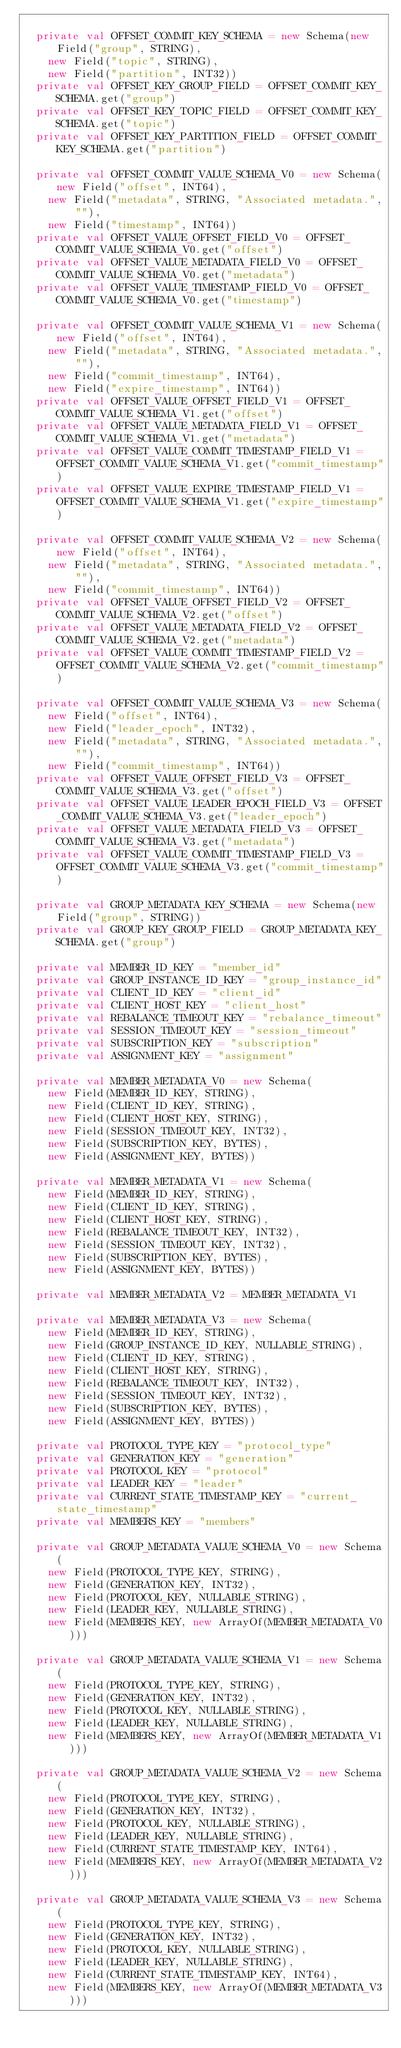<code> <loc_0><loc_0><loc_500><loc_500><_Scala_>
  private val OFFSET_COMMIT_KEY_SCHEMA = new Schema(new Field("group", STRING),
    new Field("topic", STRING),
    new Field("partition", INT32))
  private val OFFSET_KEY_GROUP_FIELD = OFFSET_COMMIT_KEY_SCHEMA.get("group")
  private val OFFSET_KEY_TOPIC_FIELD = OFFSET_COMMIT_KEY_SCHEMA.get("topic")
  private val OFFSET_KEY_PARTITION_FIELD = OFFSET_COMMIT_KEY_SCHEMA.get("partition")

  private val OFFSET_COMMIT_VALUE_SCHEMA_V0 = new Schema(new Field("offset", INT64),
    new Field("metadata", STRING, "Associated metadata.", ""),
    new Field("timestamp", INT64))
  private val OFFSET_VALUE_OFFSET_FIELD_V0 = OFFSET_COMMIT_VALUE_SCHEMA_V0.get("offset")
  private val OFFSET_VALUE_METADATA_FIELD_V0 = OFFSET_COMMIT_VALUE_SCHEMA_V0.get("metadata")
  private val OFFSET_VALUE_TIMESTAMP_FIELD_V0 = OFFSET_COMMIT_VALUE_SCHEMA_V0.get("timestamp")

  private val OFFSET_COMMIT_VALUE_SCHEMA_V1 = new Schema(new Field("offset", INT64),
    new Field("metadata", STRING, "Associated metadata.", ""),
    new Field("commit_timestamp", INT64),
    new Field("expire_timestamp", INT64))
  private val OFFSET_VALUE_OFFSET_FIELD_V1 = OFFSET_COMMIT_VALUE_SCHEMA_V1.get("offset")
  private val OFFSET_VALUE_METADATA_FIELD_V1 = OFFSET_COMMIT_VALUE_SCHEMA_V1.get("metadata")
  private val OFFSET_VALUE_COMMIT_TIMESTAMP_FIELD_V1 = OFFSET_COMMIT_VALUE_SCHEMA_V1.get("commit_timestamp")
  private val OFFSET_VALUE_EXPIRE_TIMESTAMP_FIELD_V1 = OFFSET_COMMIT_VALUE_SCHEMA_V1.get("expire_timestamp")

  private val OFFSET_COMMIT_VALUE_SCHEMA_V2 = new Schema(new Field("offset", INT64),
    new Field("metadata", STRING, "Associated metadata.", ""),
    new Field("commit_timestamp", INT64))
  private val OFFSET_VALUE_OFFSET_FIELD_V2 = OFFSET_COMMIT_VALUE_SCHEMA_V2.get("offset")
  private val OFFSET_VALUE_METADATA_FIELD_V2 = OFFSET_COMMIT_VALUE_SCHEMA_V2.get("metadata")
  private val OFFSET_VALUE_COMMIT_TIMESTAMP_FIELD_V2 = OFFSET_COMMIT_VALUE_SCHEMA_V2.get("commit_timestamp")

  private val OFFSET_COMMIT_VALUE_SCHEMA_V3 = new Schema(
    new Field("offset", INT64),
    new Field("leader_epoch", INT32),
    new Field("metadata", STRING, "Associated metadata.", ""),
    new Field("commit_timestamp", INT64))
  private val OFFSET_VALUE_OFFSET_FIELD_V3 = OFFSET_COMMIT_VALUE_SCHEMA_V3.get("offset")
  private val OFFSET_VALUE_LEADER_EPOCH_FIELD_V3 = OFFSET_COMMIT_VALUE_SCHEMA_V3.get("leader_epoch")
  private val OFFSET_VALUE_METADATA_FIELD_V3 = OFFSET_COMMIT_VALUE_SCHEMA_V3.get("metadata")
  private val OFFSET_VALUE_COMMIT_TIMESTAMP_FIELD_V3 = OFFSET_COMMIT_VALUE_SCHEMA_V3.get("commit_timestamp")

  private val GROUP_METADATA_KEY_SCHEMA = new Schema(new Field("group", STRING))
  private val GROUP_KEY_GROUP_FIELD = GROUP_METADATA_KEY_SCHEMA.get("group")

  private val MEMBER_ID_KEY = "member_id"
  private val GROUP_INSTANCE_ID_KEY = "group_instance_id"
  private val CLIENT_ID_KEY = "client_id"
  private val CLIENT_HOST_KEY = "client_host"
  private val REBALANCE_TIMEOUT_KEY = "rebalance_timeout"
  private val SESSION_TIMEOUT_KEY = "session_timeout"
  private val SUBSCRIPTION_KEY = "subscription"
  private val ASSIGNMENT_KEY = "assignment"

  private val MEMBER_METADATA_V0 = new Schema(
    new Field(MEMBER_ID_KEY, STRING),
    new Field(CLIENT_ID_KEY, STRING),
    new Field(CLIENT_HOST_KEY, STRING),
    new Field(SESSION_TIMEOUT_KEY, INT32),
    new Field(SUBSCRIPTION_KEY, BYTES),
    new Field(ASSIGNMENT_KEY, BYTES))

  private val MEMBER_METADATA_V1 = new Schema(
    new Field(MEMBER_ID_KEY, STRING),
    new Field(CLIENT_ID_KEY, STRING),
    new Field(CLIENT_HOST_KEY, STRING),
    new Field(REBALANCE_TIMEOUT_KEY, INT32),
    new Field(SESSION_TIMEOUT_KEY, INT32),
    new Field(SUBSCRIPTION_KEY, BYTES),
    new Field(ASSIGNMENT_KEY, BYTES))

  private val MEMBER_METADATA_V2 = MEMBER_METADATA_V1

  private val MEMBER_METADATA_V3 = new Schema(
    new Field(MEMBER_ID_KEY, STRING),
    new Field(GROUP_INSTANCE_ID_KEY, NULLABLE_STRING),
    new Field(CLIENT_ID_KEY, STRING),
    new Field(CLIENT_HOST_KEY, STRING),
    new Field(REBALANCE_TIMEOUT_KEY, INT32),
    new Field(SESSION_TIMEOUT_KEY, INT32),
    new Field(SUBSCRIPTION_KEY, BYTES),
    new Field(ASSIGNMENT_KEY, BYTES))

  private val PROTOCOL_TYPE_KEY = "protocol_type"
  private val GENERATION_KEY = "generation"
  private val PROTOCOL_KEY = "protocol"
  private val LEADER_KEY = "leader"
  private val CURRENT_STATE_TIMESTAMP_KEY = "current_state_timestamp"
  private val MEMBERS_KEY = "members"

  private val GROUP_METADATA_VALUE_SCHEMA_V0 = new Schema(
    new Field(PROTOCOL_TYPE_KEY, STRING),
    new Field(GENERATION_KEY, INT32),
    new Field(PROTOCOL_KEY, NULLABLE_STRING),
    new Field(LEADER_KEY, NULLABLE_STRING),
    new Field(MEMBERS_KEY, new ArrayOf(MEMBER_METADATA_V0)))

  private val GROUP_METADATA_VALUE_SCHEMA_V1 = new Schema(
    new Field(PROTOCOL_TYPE_KEY, STRING),
    new Field(GENERATION_KEY, INT32),
    new Field(PROTOCOL_KEY, NULLABLE_STRING),
    new Field(LEADER_KEY, NULLABLE_STRING),
    new Field(MEMBERS_KEY, new ArrayOf(MEMBER_METADATA_V1)))

  private val GROUP_METADATA_VALUE_SCHEMA_V2 = new Schema(
    new Field(PROTOCOL_TYPE_KEY, STRING),
    new Field(GENERATION_KEY, INT32),
    new Field(PROTOCOL_KEY, NULLABLE_STRING),
    new Field(LEADER_KEY, NULLABLE_STRING),
    new Field(CURRENT_STATE_TIMESTAMP_KEY, INT64),
    new Field(MEMBERS_KEY, new ArrayOf(MEMBER_METADATA_V2)))

  private val GROUP_METADATA_VALUE_SCHEMA_V3 = new Schema(
    new Field(PROTOCOL_TYPE_KEY, STRING),
    new Field(GENERATION_KEY, INT32),
    new Field(PROTOCOL_KEY, NULLABLE_STRING),
    new Field(LEADER_KEY, NULLABLE_STRING),
    new Field(CURRENT_STATE_TIMESTAMP_KEY, INT64),
    new Field(MEMBERS_KEY, new ArrayOf(MEMBER_METADATA_V3)))
</code> 